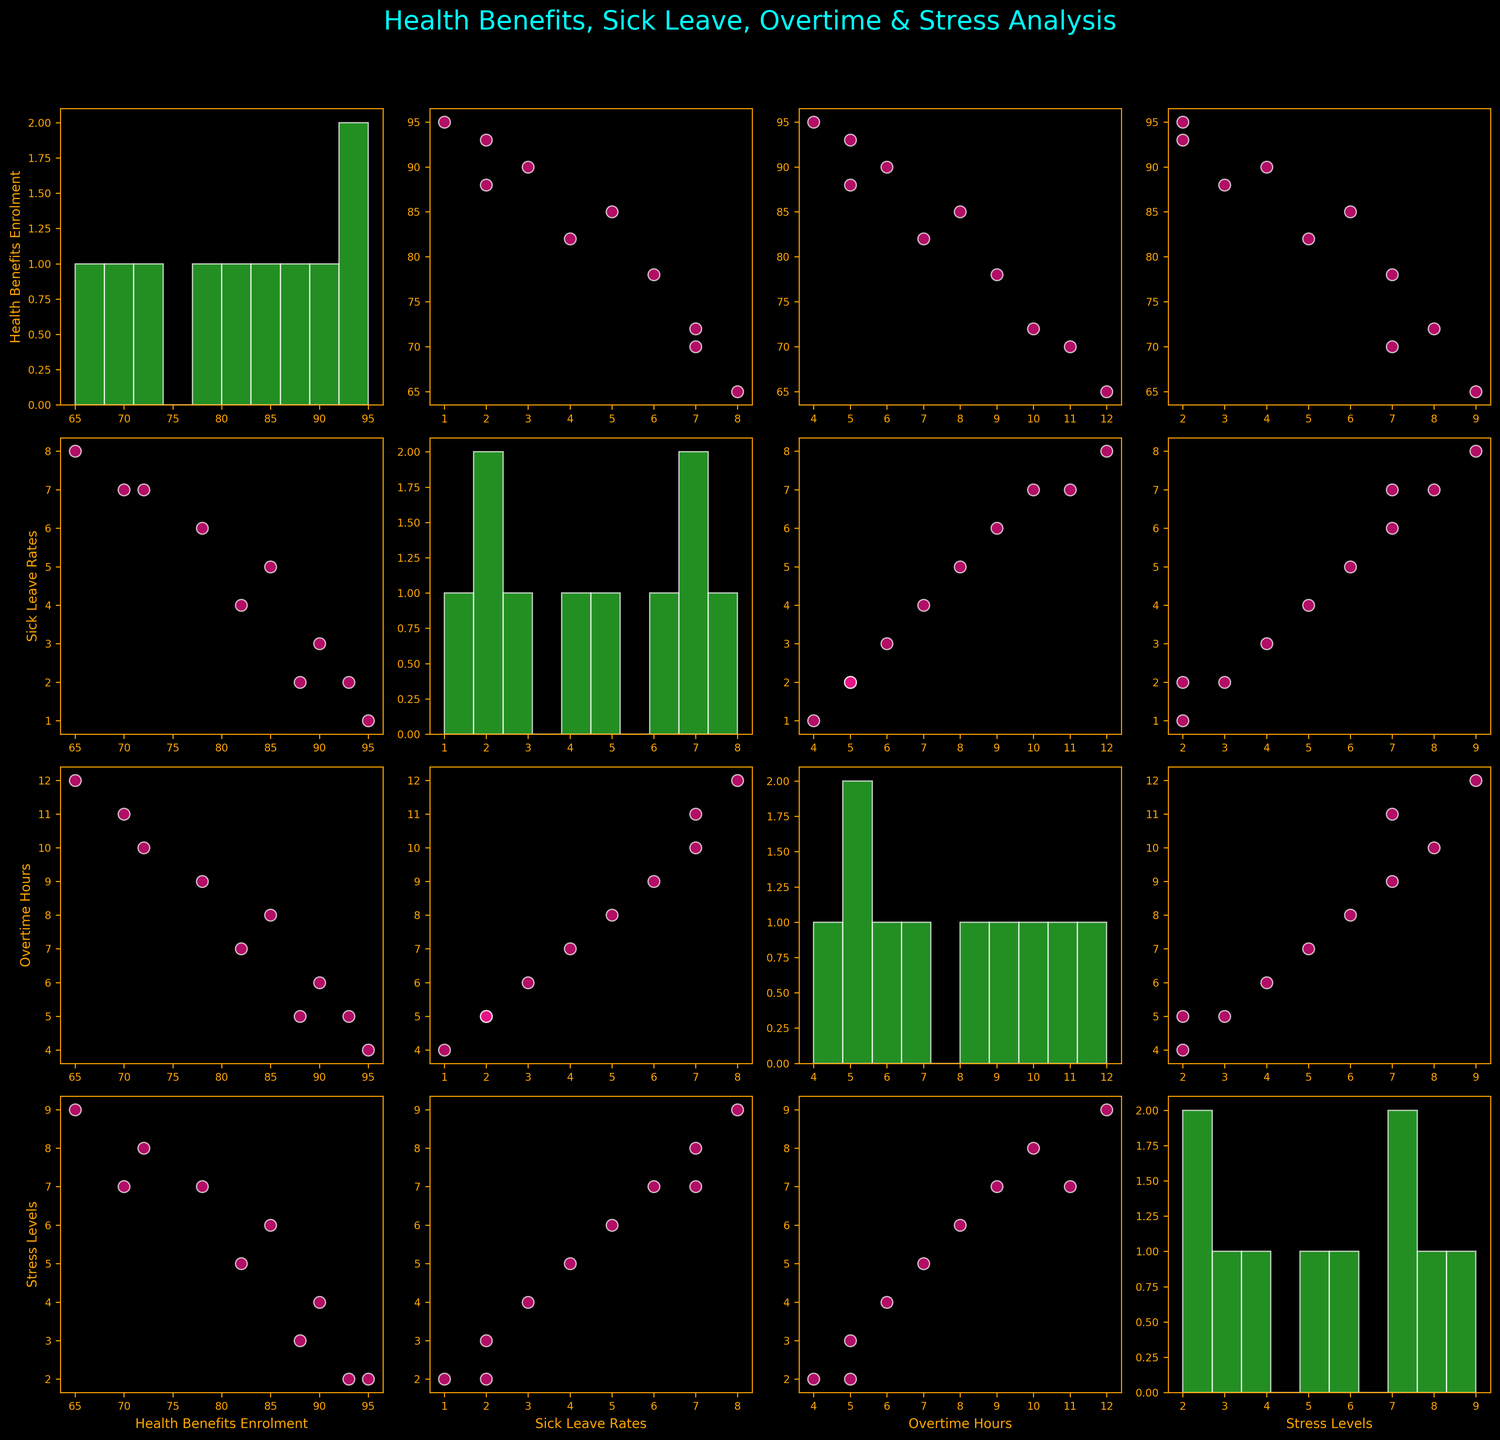What's the color theme used in the plot? The plot employs a "dark background" style with elements like points in pink, histograms in green, and axes labels in orange. The general color scheme is visually dark with vibrant highlights to distinguish elements.
Answer: Dark background with vibrant highlights What is the title of the figure? The plot's title is located at the top center and reads, "Health Benefits, Sick Leave, Overtime & Stress Analysis" in a bright cyan-blue color.
Answer: Health Benefits, Sick Leave, Overtime & Stress Analysis How many data points are in each scatter plot? By examining the scatter plots, you can count the number of distinct points. Each scatter plot has 10 data points, as each variable pair is plotted for all entries in the dataset.
Answer: 10 Which pair of variables appears to have the strongest negative correlation? By visually inspecting the scatter plots, the pair of 'Health Benefits Enrolment' and 'Stress Levels' shows a clear downward trend, indicating a strong negative correlation.
Answer: Health Benefits Enrolment and Stress Levels Which variable has the highest variability in its histogram? Looking at the width and spread of different histograms, 'Health Benefits Enrolment' has a wide spread compared to others, indicating high variability.
Answer: Health Benefits Enrolment What is the relationship between Sick Leave Rates and Stress Levels? By inspecting the scatter plot between 'Sick Leave Rates' and 'Stress Levels', there appears to be a positive correlation, where higher stress levels are associated with higher sick leave rates.
Answer: Positive correlation Which scatter plot shows the closest clustering of data points? Observing the scatter plots, the 'Health Benefits Enrolment vs. Sick Leave Rates' plot shows tightly clustered points suggesting little variation between these variables.
Answer: Health Benefits Enrolment vs. Sick Leave Rates What can be inferred about the relationship between Overtime Hours and Stress Levels? From the scatter plot, we observe that higher overtime hours tend to be associated with higher stress levels, indicating a positive correlation.
Answer: Positive correlation Compare the spread of 'Overtime Hours' in the histogram to 'Sick Leave Rates'. By looking at the histograms for these variables, it is evident that 'Overtime Hours' demonstrates a wider spread of data than 'Sick Leave Rates', suggesting more variability in overtime hours.
Answer: Overtime Hours has a wider spread Is there evidence that higher Health Benefits Enrolment reduces Stress Levels? Examining the scatter plot between 'Health Benefits Enrolment' and 'Stress Levels', there is a noticeable downward trend, indicating that higher health benefits enrolment is associated with lower stress levels.
Answer: Yes 